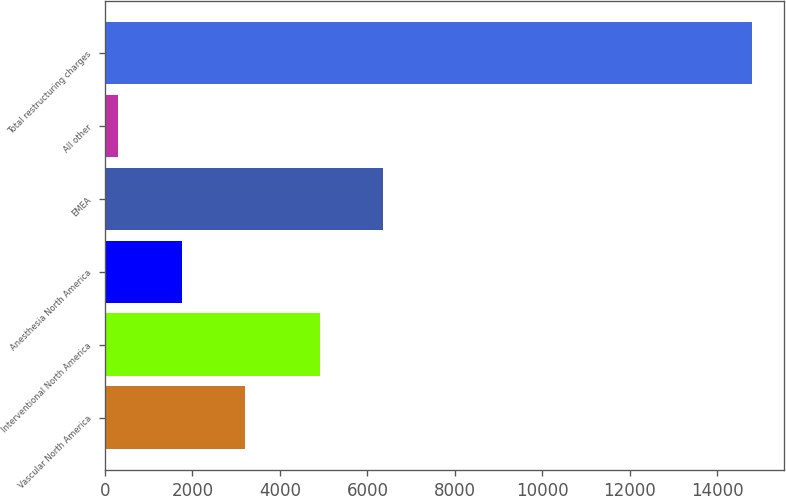Convert chart to OTSL. <chart><loc_0><loc_0><loc_500><loc_500><bar_chart><fcel>Vascular North America<fcel>Interventional North America<fcel>Anesthesia North America<fcel>EMEA<fcel>All other<fcel>Total restructuring charges<nl><fcel>3200.4<fcel>4908<fcel>1751.7<fcel>6356.7<fcel>303<fcel>14790<nl></chart> 